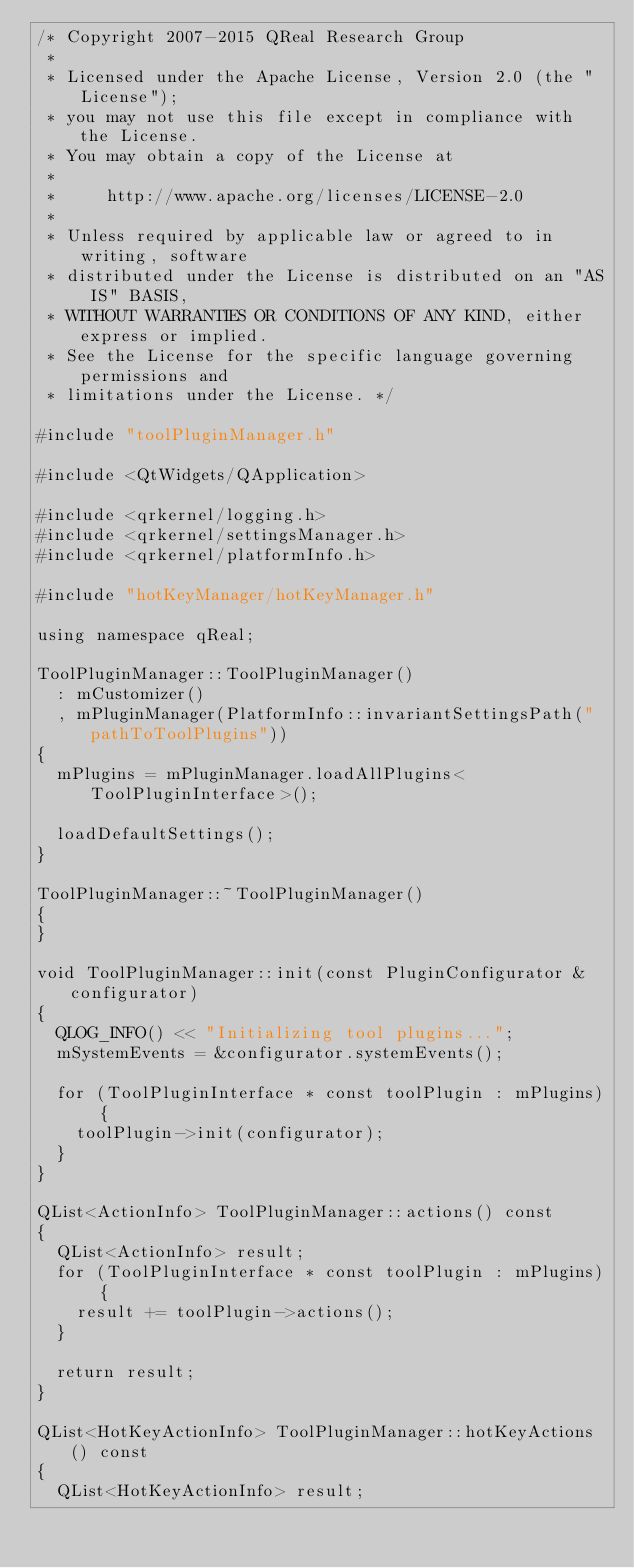<code> <loc_0><loc_0><loc_500><loc_500><_C++_>/* Copyright 2007-2015 QReal Research Group
 *
 * Licensed under the Apache License, Version 2.0 (the "License");
 * you may not use this file except in compliance with the License.
 * You may obtain a copy of the License at
 *
 *     http://www.apache.org/licenses/LICENSE-2.0
 *
 * Unless required by applicable law or agreed to in writing, software
 * distributed under the License is distributed on an "AS IS" BASIS,
 * WITHOUT WARRANTIES OR CONDITIONS OF ANY KIND, either express or implied.
 * See the License for the specific language governing permissions and
 * limitations under the License. */

#include "toolPluginManager.h"

#include <QtWidgets/QApplication>

#include <qrkernel/logging.h>
#include <qrkernel/settingsManager.h>
#include <qrkernel/platformInfo.h>

#include "hotKeyManager/hotKeyManager.h"

using namespace qReal;

ToolPluginManager::ToolPluginManager()
	: mCustomizer()
	, mPluginManager(PlatformInfo::invariantSettingsPath("pathToToolPlugins"))
{
	mPlugins = mPluginManager.loadAllPlugins<ToolPluginInterface>();

	loadDefaultSettings();
}

ToolPluginManager::~ToolPluginManager()
{
}

void ToolPluginManager::init(const PluginConfigurator &configurator)
{
	QLOG_INFO() << "Initializing tool plugins...";
	mSystemEvents = &configurator.systemEvents();

	for (ToolPluginInterface * const toolPlugin : mPlugins) {
		toolPlugin->init(configurator);
	}
}

QList<ActionInfo> ToolPluginManager::actions() const
{
	QList<ActionInfo> result;
	for (ToolPluginInterface * const toolPlugin : mPlugins) {
		result += toolPlugin->actions();
	}

	return result;
}

QList<HotKeyActionInfo> ToolPluginManager::hotKeyActions() const
{
	QList<HotKeyActionInfo> result;</code> 